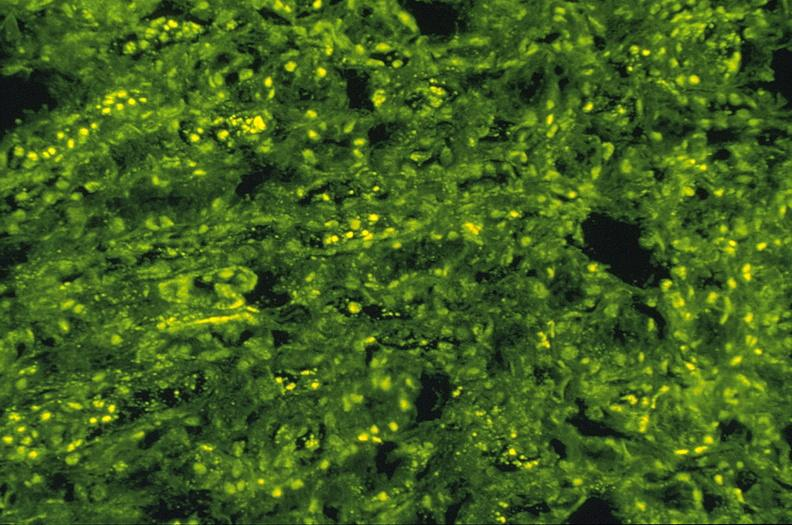does cysticercosis show sle iv, ana staining, kappa, 10x?
Answer the question using a single word or phrase. No 